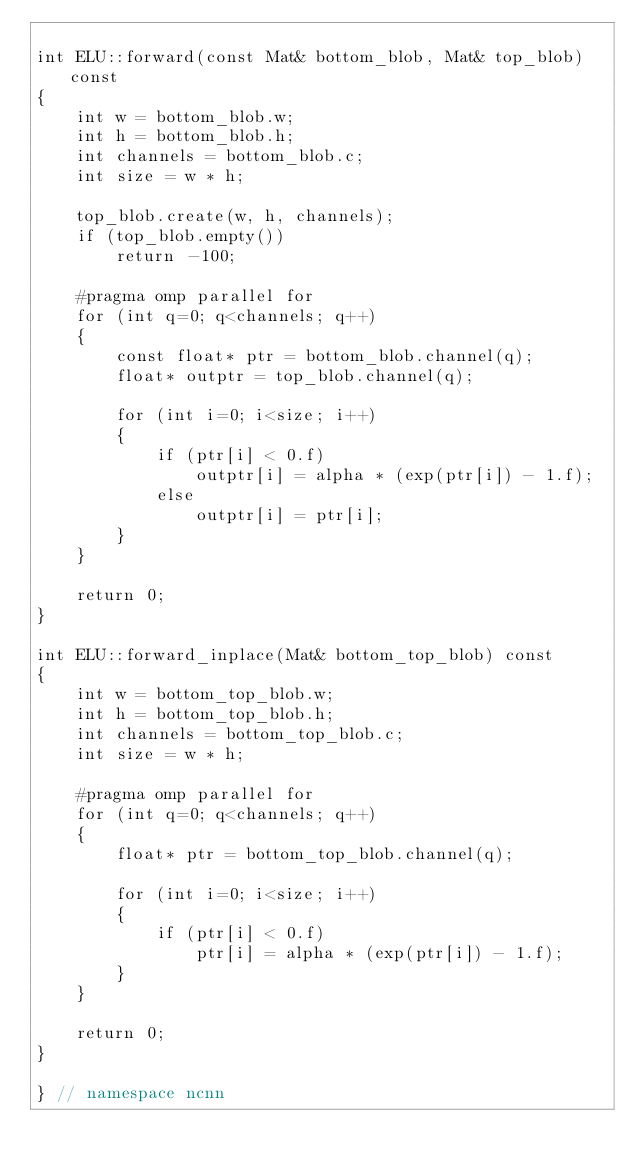Convert code to text. <code><loc_0><loc_0><loc_500><loc_500><_C++_>
int ELU::forward(const Mat& bottom_blob, Mat& top_blob) const
{
    int w = bottom_blob.w;
    int h = bottom_blob.h;
    int channels = bottom_blob.c;
    int size = w * h;

    top_blob.create(w, h, channels);
    if (top_blob.empty())
        return -100;

    #pragma omp parallel for
    for (int q=0; q<channels; q++)
    {
        const float* ptr = bottom_blob.channel(q);
        float* outptr = top_blob.channel(q);

        for (int i=0; i<size; i++)
        {
            if (ptr[i] < 0.f)
                outptr[i] = alpha * (exp(ptr[i]) - 1.f);
            else
                outptr[i] = ptr[i];
        }
    }

    return 0;
}

int ELU::forward_inplace(Mat& bottom_top_blob) const
{
    int w = bottom_top_blob.w;
    int h = bottom_top_blob.h;
    int channels = bottom_top_blob.c;
    int size = w * h;

    #pragma omp parallel for
    for (int q=0; q<channels; q++)
    {
        float* ptr = bottom_top_blob.channel(q);

        for (int i=0; i<size; i++)
        {
            if (ptr[i] < 0.f)
                ptr[i] = alpha * (exp(ptr[i]) - 1.f);
        }
    }

    return 0;
}

} // namespace ncnn
</code> 